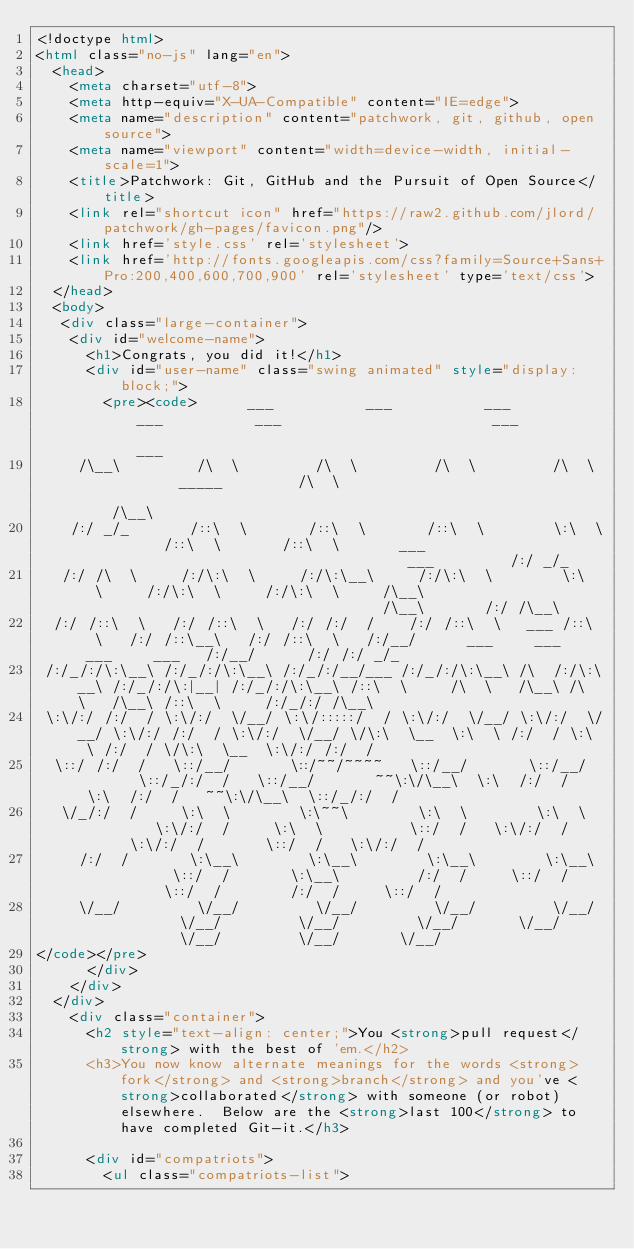<code> <loc_0><loc_0><loc_500><loc_500><_HTML_><!doctype html>
<html class="no-js" lang="en">
  <head>
    <meta charset="utf-8">
    <meta http-equiv="X-UA-Compatible" content="IE=edge">
    <meta name="description" content="patchwork, git, github, open source">
    <meta name="viewport" content="width=device-width, initial-scale=1">
    <title>Patchwork: Git, GitHub and the Pursuit of Open Source</title>
    <link rel="shortcut icon" href="https://raw2.github.com/jlord/patchwork/gh-pages/favicon.png"/>
    <link href='style.css' rel='stylesheet'>
    <link href='http://fonts.googleapis.com/css?family=Source+Sans+Pro:200,400,600,700,900' rel='stylesheet' type='text/css'>
  </head>
  <body>
   <div class="large-container">
    <div id="welcome-name">
      <h1>Congrats, you did it!</h1>
      <div id="user-name" class="swing animated" style="display: block;">
        <pre><code>      ___           ___           ___           ___           ___                         ___                                                               ___     
     /\__\         /\  \         /\  \         /\  \         /\  \         _____         /\  \                                                             /\__\    
    /:/ _/_       /::\  \       /::\  \       /::\  \        \:\  \       /::\  \       /::\  \       ___                                     ___         /:/ _/_   
   /:/ /\  \     /:/\:\  \     /:/\:\__\     /:/\:\  \        \:\  \     /:/\:\  \     /:/\:\  \     /\__\                                   /\__\       /:/ /\__\  
  /:/ /::\  \   /:/ /::\  \   /:/ /:/  /    /:/ /::\  \   ___ /::\  \   /:/ /::\__\   /:/ /::\  \   /:/__/      ___     ___   ___     ___   /:/__/      /:/ /:/ _/_ 
 /:/_/:/\:\__\ /:/_/:/\:\__\ /:/_/:/__/___ /:/_/:/\:\__\ /\  /:/\:\__\ /:/_/:/\:|__| /:/_/:/\:\__\ /::\  \     /\  \   /\__\ /\  \   /\__\ /::\  \     /:/_/:/ /\__\
 \:\/:/ /:/  / \:\/:/  \/__/ \:\/:::::/  / \:\/:/  \/__/ \:\/:/  \/__/ \:\/:/ /:/  / \:\/:/  \/__/ \/\:\  \__  \:\  \ /:/  / \:\  \ /:/  / \/\:\  \__  \:\/:/ /:/  /
  \::/ /:/  /   \::/__/       \::/~~/~~~~   \::/__/       \::/__/       \::/_/:/  /   \::/__/       ~~\:\/\__\  \:\  /:/  /   \:\  /:/  /   ~~\:\/\__\  \::/_/:/  / 
   \/_/:/  /     \:\  \        \:\~~\        \:\  \        \:\  \        \:\/:/  /     \:\  \          \::/  /   \:\/:/  /     \:\/:/  /       \::/  /   \:\/:/  /  
     /:/  /       \:\__\        \:\__\        \:\__\        \:\__\        \::/  /       \:\__\         /:/  /     \::/  /       \::/  /        /:/  /     \::/  /   
     \/__/         \/__/         \/__/         \/__/         \/__/         \/__/         \/__/         \/__/       \/__/         \/__/         \/__/       \/__/    
</code></pre>
      </div>
    </div>
  </div>
    <div class="container">
      <h2 style="text-align: center;">You <strong>pull request</strong> with the best of 'em.</h2>
      <h3>You now know alternate meanings for the words <strong>fork</strong> and <strong>branch</strong> and you've <strong>collaborated</strong> with someone (or robot) elsewhere.  Below are the <strong>last 100</strong> to have completed Git-it.</h3>

      <div id="compatriots">
        <ul class="compatriots-list"></code> 